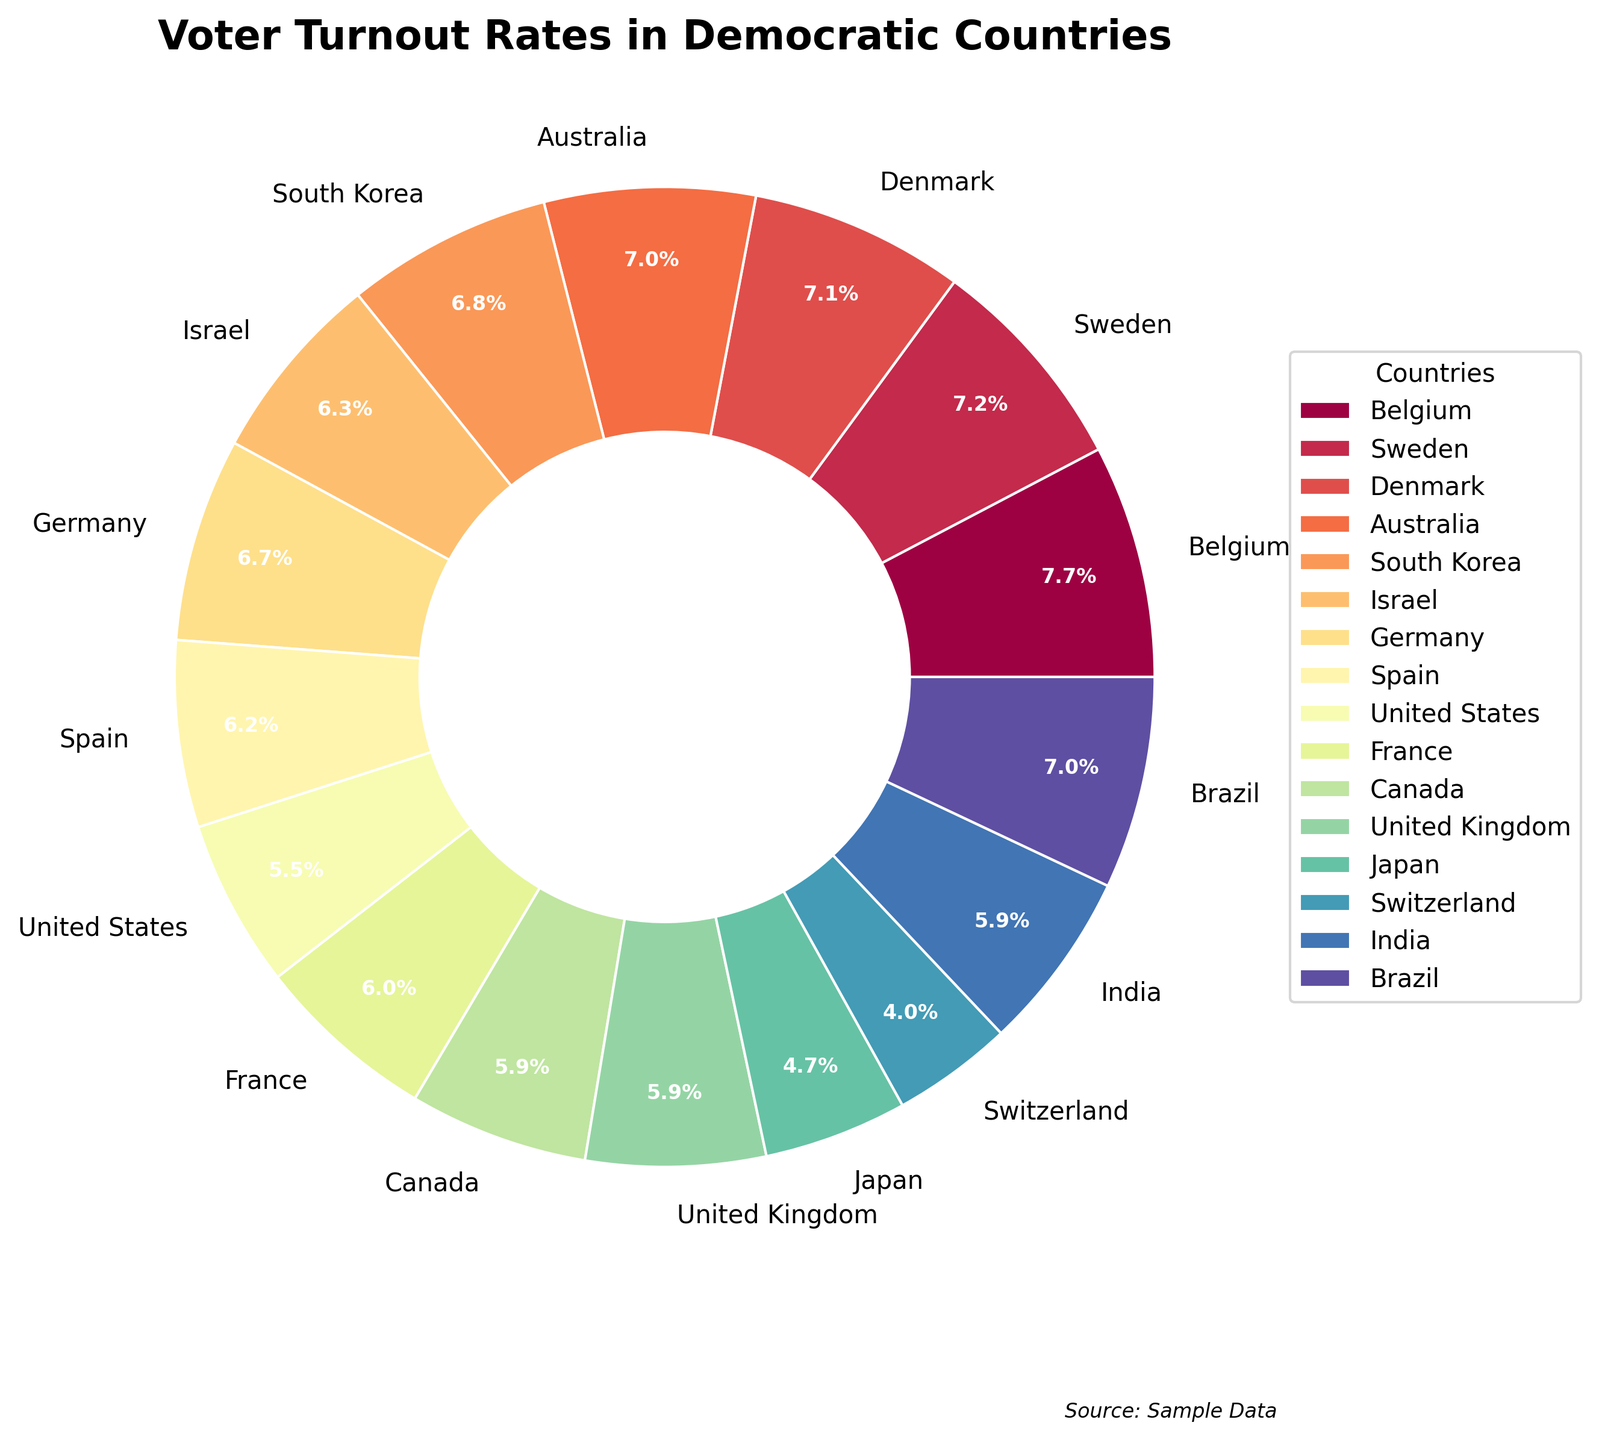What's the voter turnout rate in Belgium? Belgium's voter turnout rate is provided in the data table and represented as a section of the pie chart. By referring to the key and the chart, we see that Belgium's rate is the highest at 87.2%.
Answer: 87.2% Which country has the lowest voter turnout rate? The pie chart segments show varying sizes representing the voter turnout rates. The smallest segment corresponds to Switzerland, which has the lowest voter turnout rate.
Answer: Switzerland How does Switzerland's voter turnout compare to Japan's? By observing the pie chart, the segment for Switzerland is smaller than that for Japan. The voter turnout rate for Switzerland is 45.1%, whereas for Japan, it is 53.7%. Therefore, Switzerland has a lower rate compared to Japan.
Answer: Switzerland is lower What's the difference in voter turnout rates between the United States and Belgium? According to the pie chart, the United States has a turnout rate of 62.8%, and Belgium has 87.2%. Subtracting the US rate from Belgium's rate: 87.2% - 62.8% = 24.4%.
Answer: 24.4% What is the combined voter turnout rate of Israel, Germany, and Spain? To find the combined turnout rate, we add the individual rates: Israel (71.5%), Germany (76.2%), and Spain (69.9%). The total is 71.5% + 76.2% + 69.9% = 217.6%.
Answer: 217.6% Does Brazil have a higher turnout rate than Australia? Looking at the pie chart, Brazil has a larger segment compared to Australia. Brazil's voter turnout rate is 79.5%, which is higher than Australia's rate of 78.9%.
Answer: Yes What countries have a voter turnout rate below 70%? By examining the pie chart and the data, the countries with a turnout rate below 70% are Israel (71.5%), Spain (69.9%), United States (62.8%), France (67.9%), Canada (67.0%), United Kingdom (67.3%), Japan (53.7%), and Switzerland (45.1%). Removing those above 70%, the remaining are Spain, United States, Japan, and Switzerland.
Answer: Spain, United States, Japan, Switzerland How much higher is the voter turnout in Sweden compared to the United Kingdom? The pie chart shows Sweden's voter turnout rate at 82.1%, and the United Kingdom's at 67.3%. The difference is 82.1% - 67.3% = 14.8%.
Answer: 14.8% What is the average voter turnout rate of the top three countries with the highest rates? By identifying the three largest segments in the pie chart, we find Belgium (87.2%), Sweden (82.1%), and Denmark (80.3%). Calculating the average: (87.2% + 82.1% + 80.3%) / 3 = 249.6% / 3 = 83.2%.
Answer: 83.2% What is the voter turnout rate difference between Canada and India? From the data, Canada has a voter turnout rate of 67.0%, while India's rate is 67.4%. The difference is 67.4% - 67.0% = 0.4%.
Answer: 0.4% 